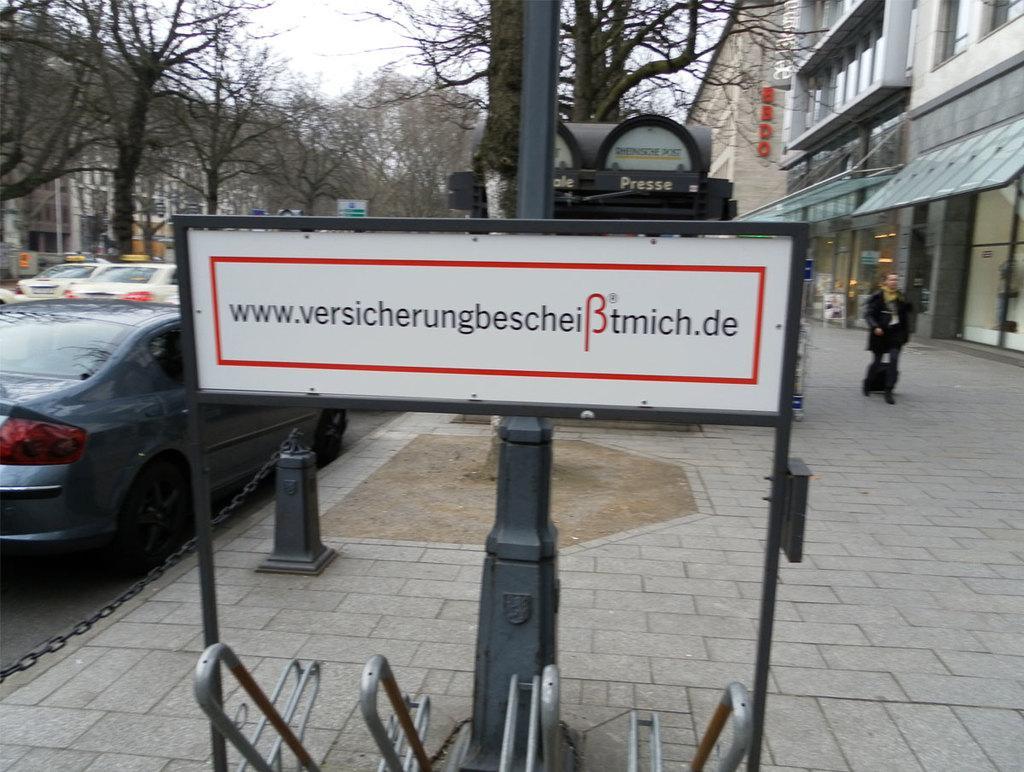Describe this image in one or two sentences. In the image we can see there is a hoarding on which there is a website written on it and there is a person standing on the footpath. There are buildings and there are trees. There are cars parked on the road. 